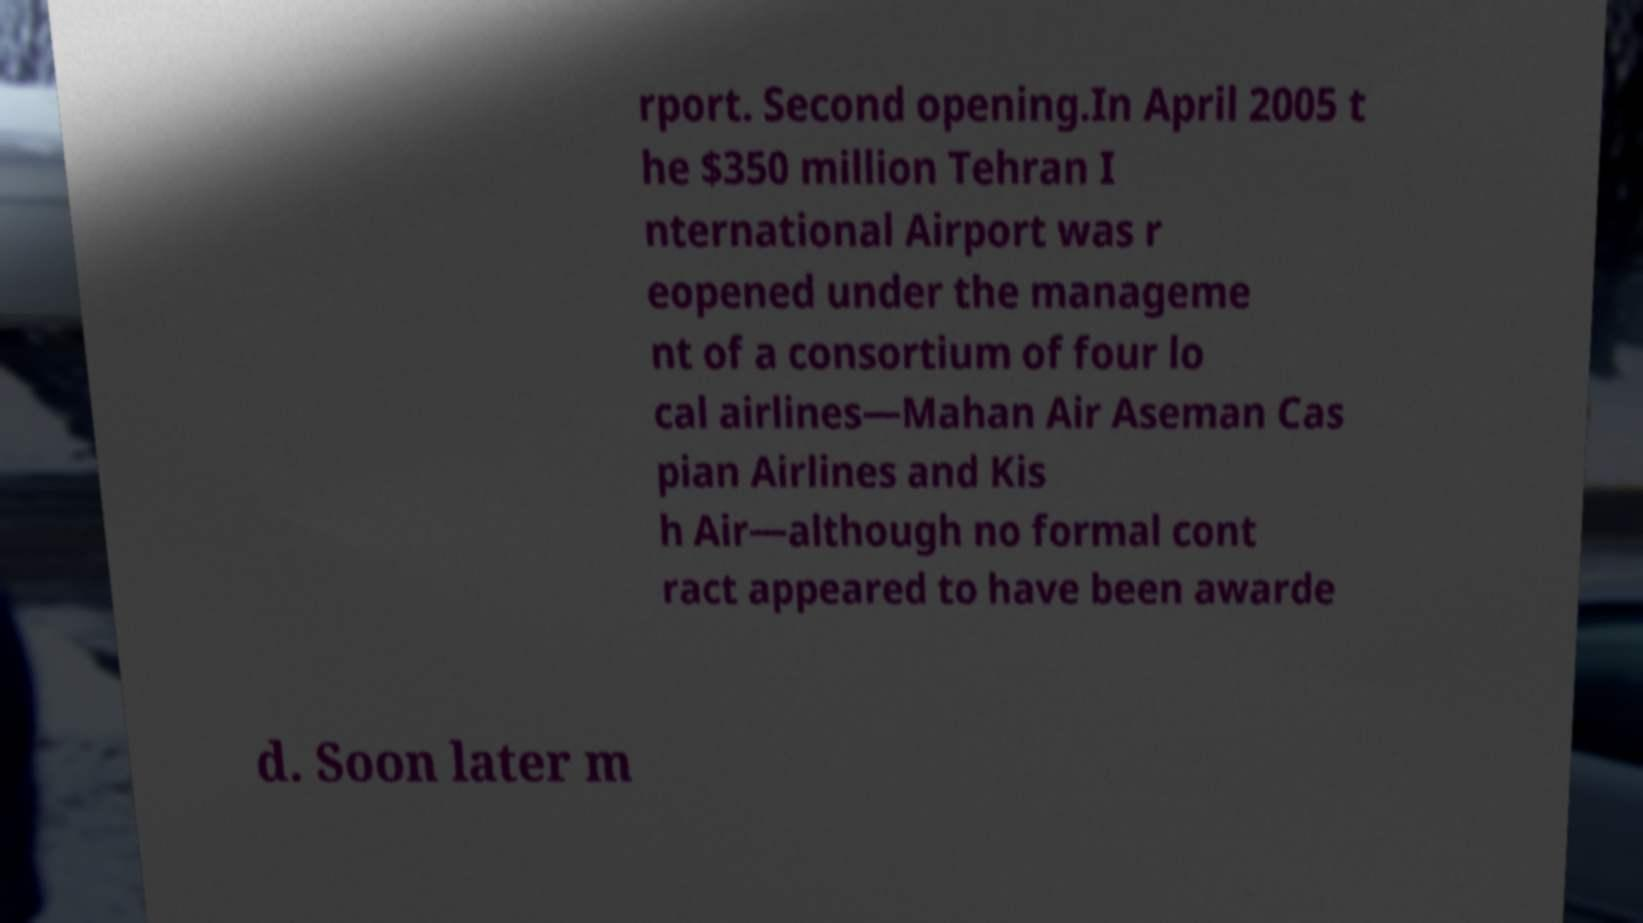For documentation purposes, I need the text within this image transcribed. Could you provide that? rport. Second opening.In April 2005 t he $350 million Tehran I nternational Airport was r eopened under the manageme nt of a consortium of four lo cal airlines—Mahan Air Aseman Cas pian Airlines and Kis h Air—although no formal cont ract appeared to have been awarde d. Soon later m 